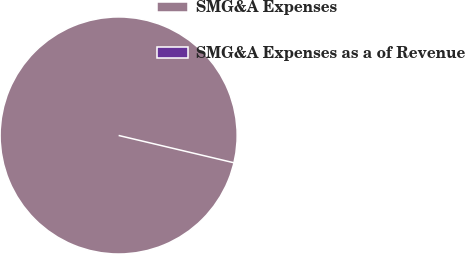Convert chart to OTSL. <chart><loc_0><loc_0><loc_500><loc_500><pie_chart><fcel>SMG&A Expenses<fcel>SMG&A Expenses as a of Revenue<nl><fcel>100.0%<fcel>0.0%<nl></chart> 